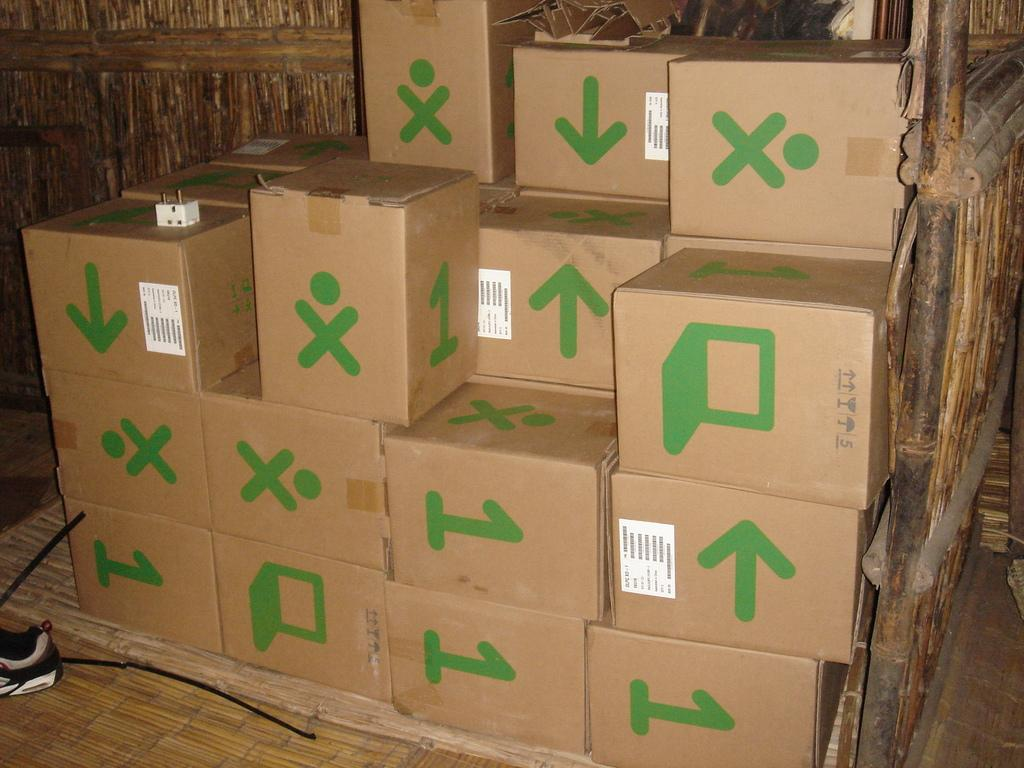<image>
Render a clear and concise summary of the photo. Several boxes with a 1 on some, a laptop, an arrow, and a stick figure. 